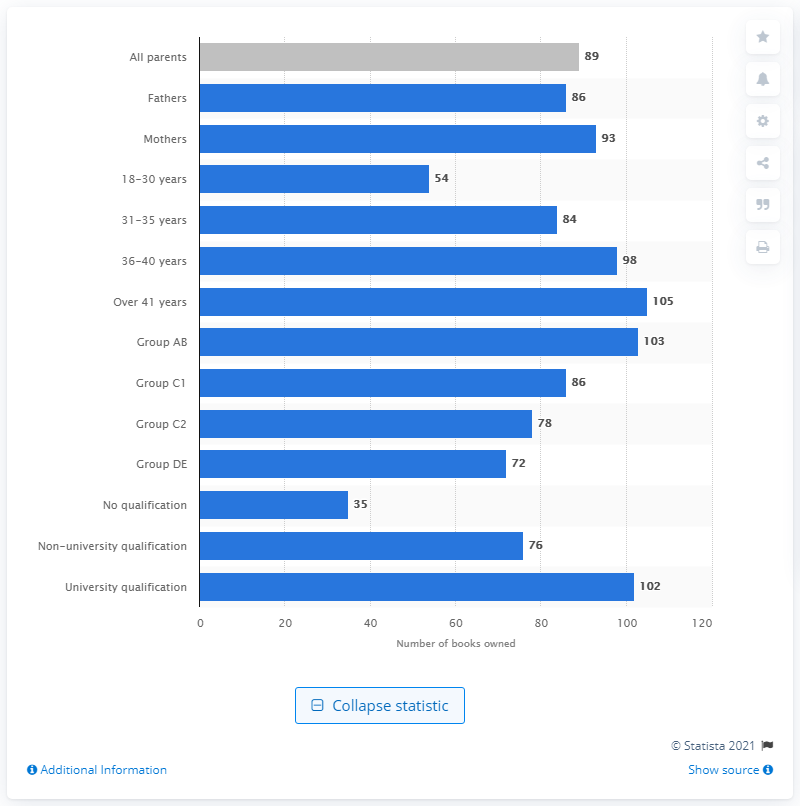Point out several critical features in this image. According to the data from 2013, the average number of children's books in the home was 105. 